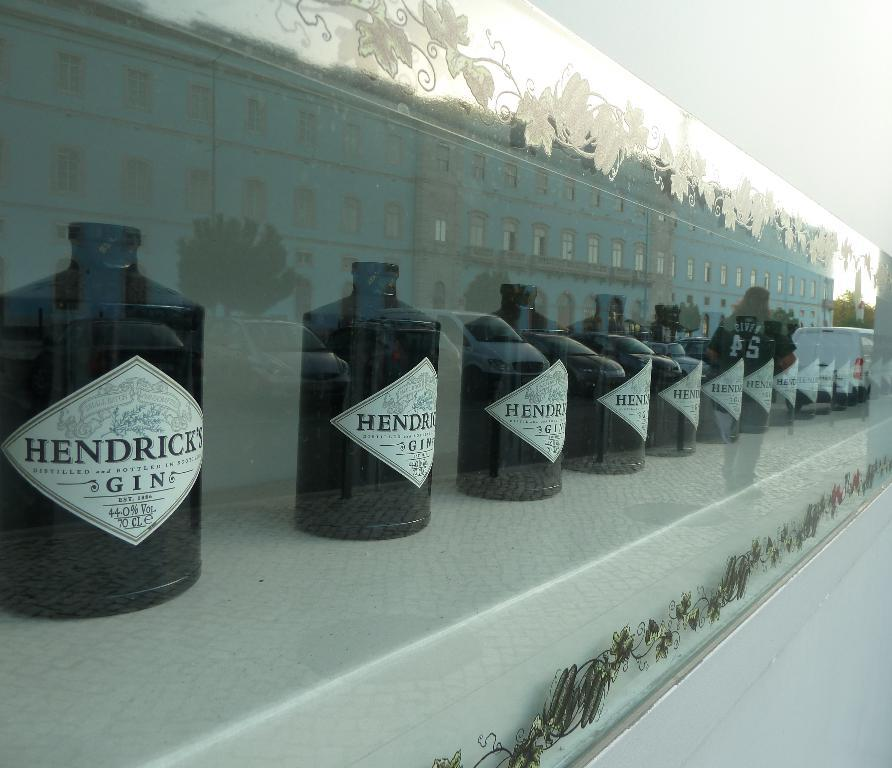Provide a one-sentence caption for the provided image. The fluid in the bottles is called Hendricks Gin. 